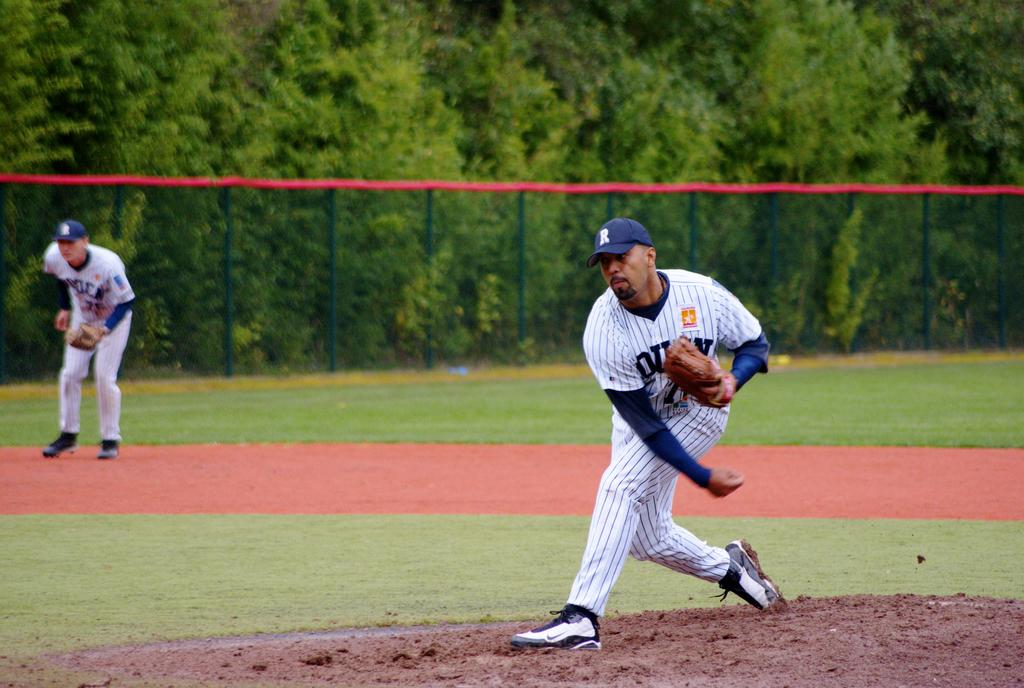Provide a one-sentence caption for the provided image. Baseball player wearing a cap with the letter R on it. 